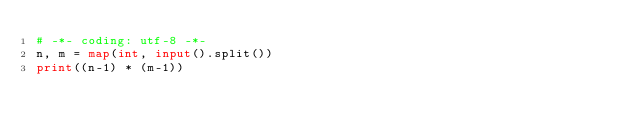Convert code to text. <code><loc_0><loc_0><loc_500><loc_500><_Python_># -*- coding: utf-8 -*-
n, m = map(int, input().split())
print((n-1) * (m-1))
</code> 